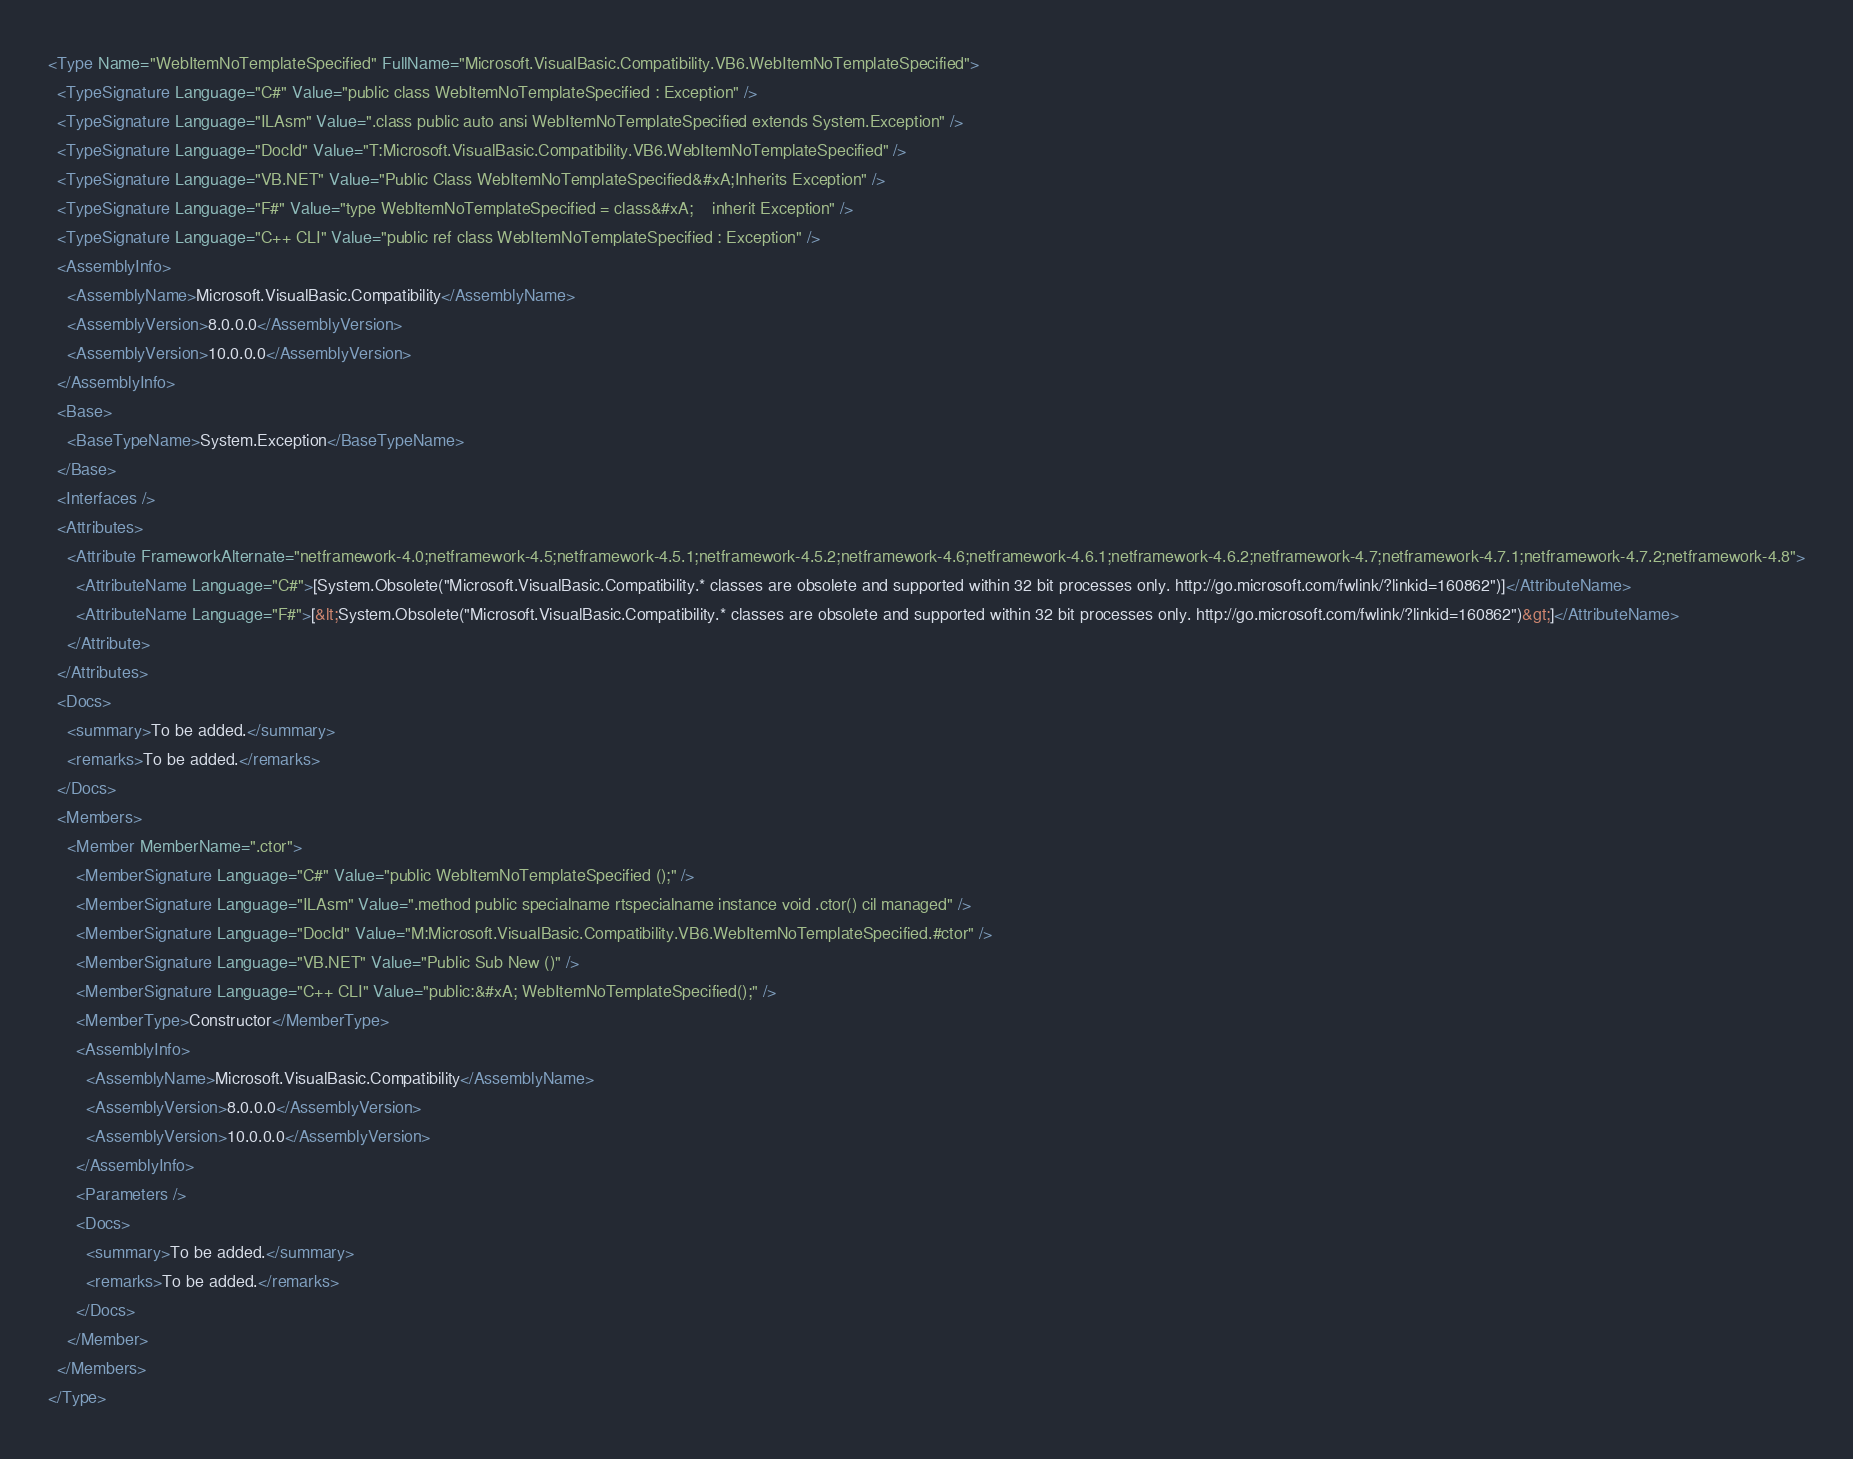<code> <loc_0><loc_0><loc_500><loc_500><_XML_><Type Name="WebItemNoTemplateSpecified" FullName="Microsoft.VisualBasic.Compatibility.VB6.WebItemNoTemplateSpecified">
  <TypeSignature Language="C#" Value="public class WebItemNoTemplateSpecified : Exception" />
  <TypeSignature Language="ILAsm" Value=".class public auto ansi WebItemNoTemplateSpecified extends System.Exception" />
  <TypeSignature Language="DocId" Value="T:Microsoft.VisualBasic.Compatibility.VB6.WebItemNoTemplateSpecified" />
  <TypeSignature Language="VB.NET" Value="Public Class WebItemNoTemplateSpecified&#xA;Inherits Exception" />
  <TypeSignature Language="F#" Value="type WebItemNoTemplateSpecified = class&#xA;    inherit Exception" />
  <TypeSignature Language="C++ CLI" Value="public ref class WebItemNoTemplateSpecified : Exception" />
  <AssemblyInfo>
    <AssemblyName>Microsoft.VisualBasic.Compatibility</AssemblyName>
    <AssemblyVersion>8.0.0.0</AssemblyVersion>
    <AssemblyVersion>10.0.0.0</AssemblyVersion>
  </AssemblyInfo>
  <Base>
    <BaseTypeName>System.Exception</BaseTypeName>
  </Base>
  <Interfaces />
  <Attributes>
    <Attribute FrameworkAlternate="netframework-4.0;netframework-4.5;netframework-4.5.1;netframework-4.5.2;netframework-4.6;netframework-4.6.1;netframework-4.6.2;netframework-4.7;netframework-4.7.1;netframework-4.7.2;netframework-4.8">
      <AttributeName Language="C#">[System.Obsolete("Microsoft.VisualBasic.Compatibility.* classes are obsolete and supported within 32 bit processes only. http://go.microsoft.com/fwlink/?linkid=160862")]</AttributeName>
      <AttributeName Language="F#">[&lt;System.Obsolete("Microsoft.VisualBasic.Compatibility.* classes are obsolete and supported within 32 bit processes only. http://go.microsoft.com/fwlink/?linkid=160862")&gt;]</AttributeName>
    </Attribute>
  </Attributes>
  <Docs>
    <summary>To be added.</summary>
    <remarks>To be added.</remarks>
  </Docs>
  <Members>
    <Member MemberName=".ctor">
      <MemberSignature Language="C#" Value="public WebItemNoTemplateSpecified ();" />
      <MemberSignature Language="ILAsm" Value=".method public specialname rtspecialname instance void .ctor() cil managed" />
      <MemberSignature Language="DocId" Value="M:Microsoft.VisualBasic.Compatibility.VB6.WebItemNoTemplateSpecified.#ctor" />
      <MemberSignature Language="VB.NET" Value="Public Sub New ()" />
      <MemberSignature Language="C++ CLI" Value="public:&#xA; WebItemNoTemplateSpecified();" />
      <MemberType>Constructor</MemberType>
      <AssemblyInfo>
        <AssemblyName>Microsoft.VisualBasic.Compatibility</AssemblyName>
        <AssemblyVersion>8.0.0.0</AssemblyVersion>
        <AssemblyVersion>10.0.0.0</AssemblyVersion>
      </AssemblyInfo>
      <Parameters />
      <Docs>
        <summary>To be added.</summary>
        <remarks>To be added.</remarks>
      </Docs>
    </Member>
  </Members>
</Type>
</code> 